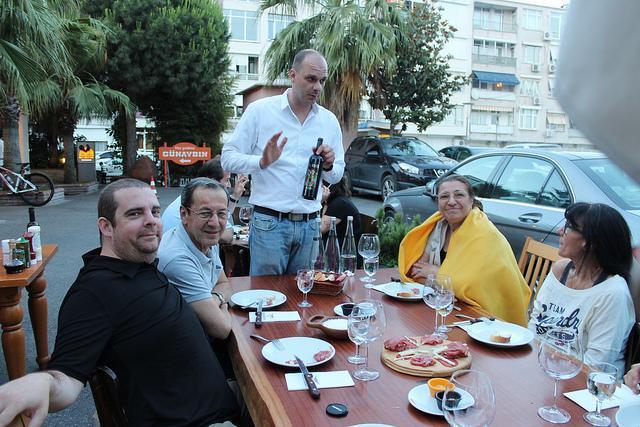How many people are in the picture?
Give a very brief answer. 5. How many glasses are in front of each person?
Give a very brief answer. 2. How many wine glasses are there?
Give a very brief answer. 2. How many cars are visible?
Give a very brief answer. 2. How many people are there?
Give a very brief answer. 5. 